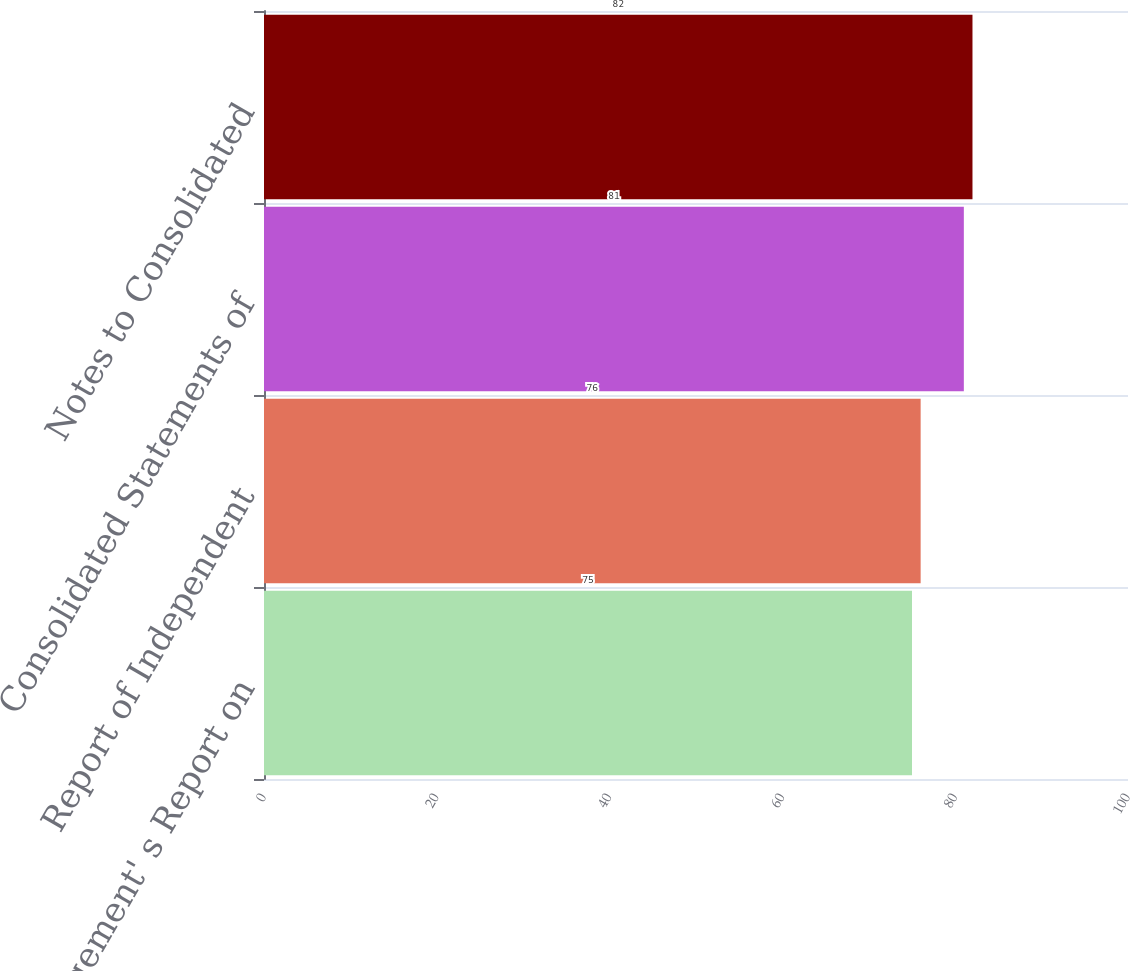Convert chart. <chart><loc_0><loc_0><loc_500><loc_500><bar_chart><fcel>Management' s Report on<fcel>Report of Independent<fcel>Consolidated Statements of<fcel>Notes to Consolidated<nl><fcel>75<fcel>76<fcel>81<fcel>82<nl></chart> 